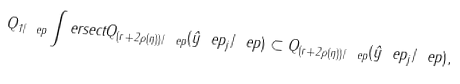<formula> <loc_0><loc_0><loc_500><loc_500>Q _ { 1 / \ e p } \int e r s e c t Q _ { ( r + 2 \rho ( \eta ) ) / \ e p } ( \hat { y } ^ { \ } e p _ { j } / \ e p ) \subset Q _ { ( r + 2 \rho ( \eta ) ) / \ e p } ( \hat { y } ^ { \ } e p _ { j } / \ e p ) ,</formula> 